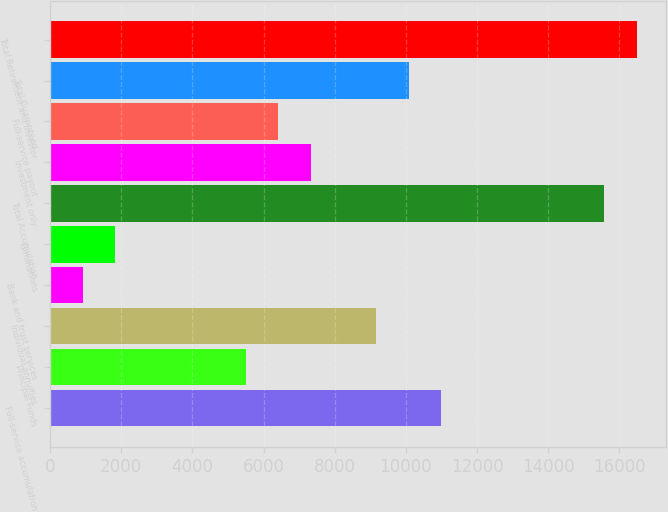<chart> <loc_0><loc_0><loc_500><loc_500><bar_chart><fcel>Full-service accumulation<fcel>Principal Funds<fcel>Individual annuities<fcel>Bank and trust services<fcel>Eliminations<fcel>Total Accumulation<fcel>Investment only<fcel>Full-service payout<fcel>Total Guaranteed<fcel>Total Retirement and Investor<nl><fcel>10990.2<fcel>5495.48<fcel>9158.6<fcel>916.58<fcel>1832.36<fcel>15569.1<fcel>7327.04<fcel>6411.26<fcel>10074.4<fcel>16484.8<nl></chart> 